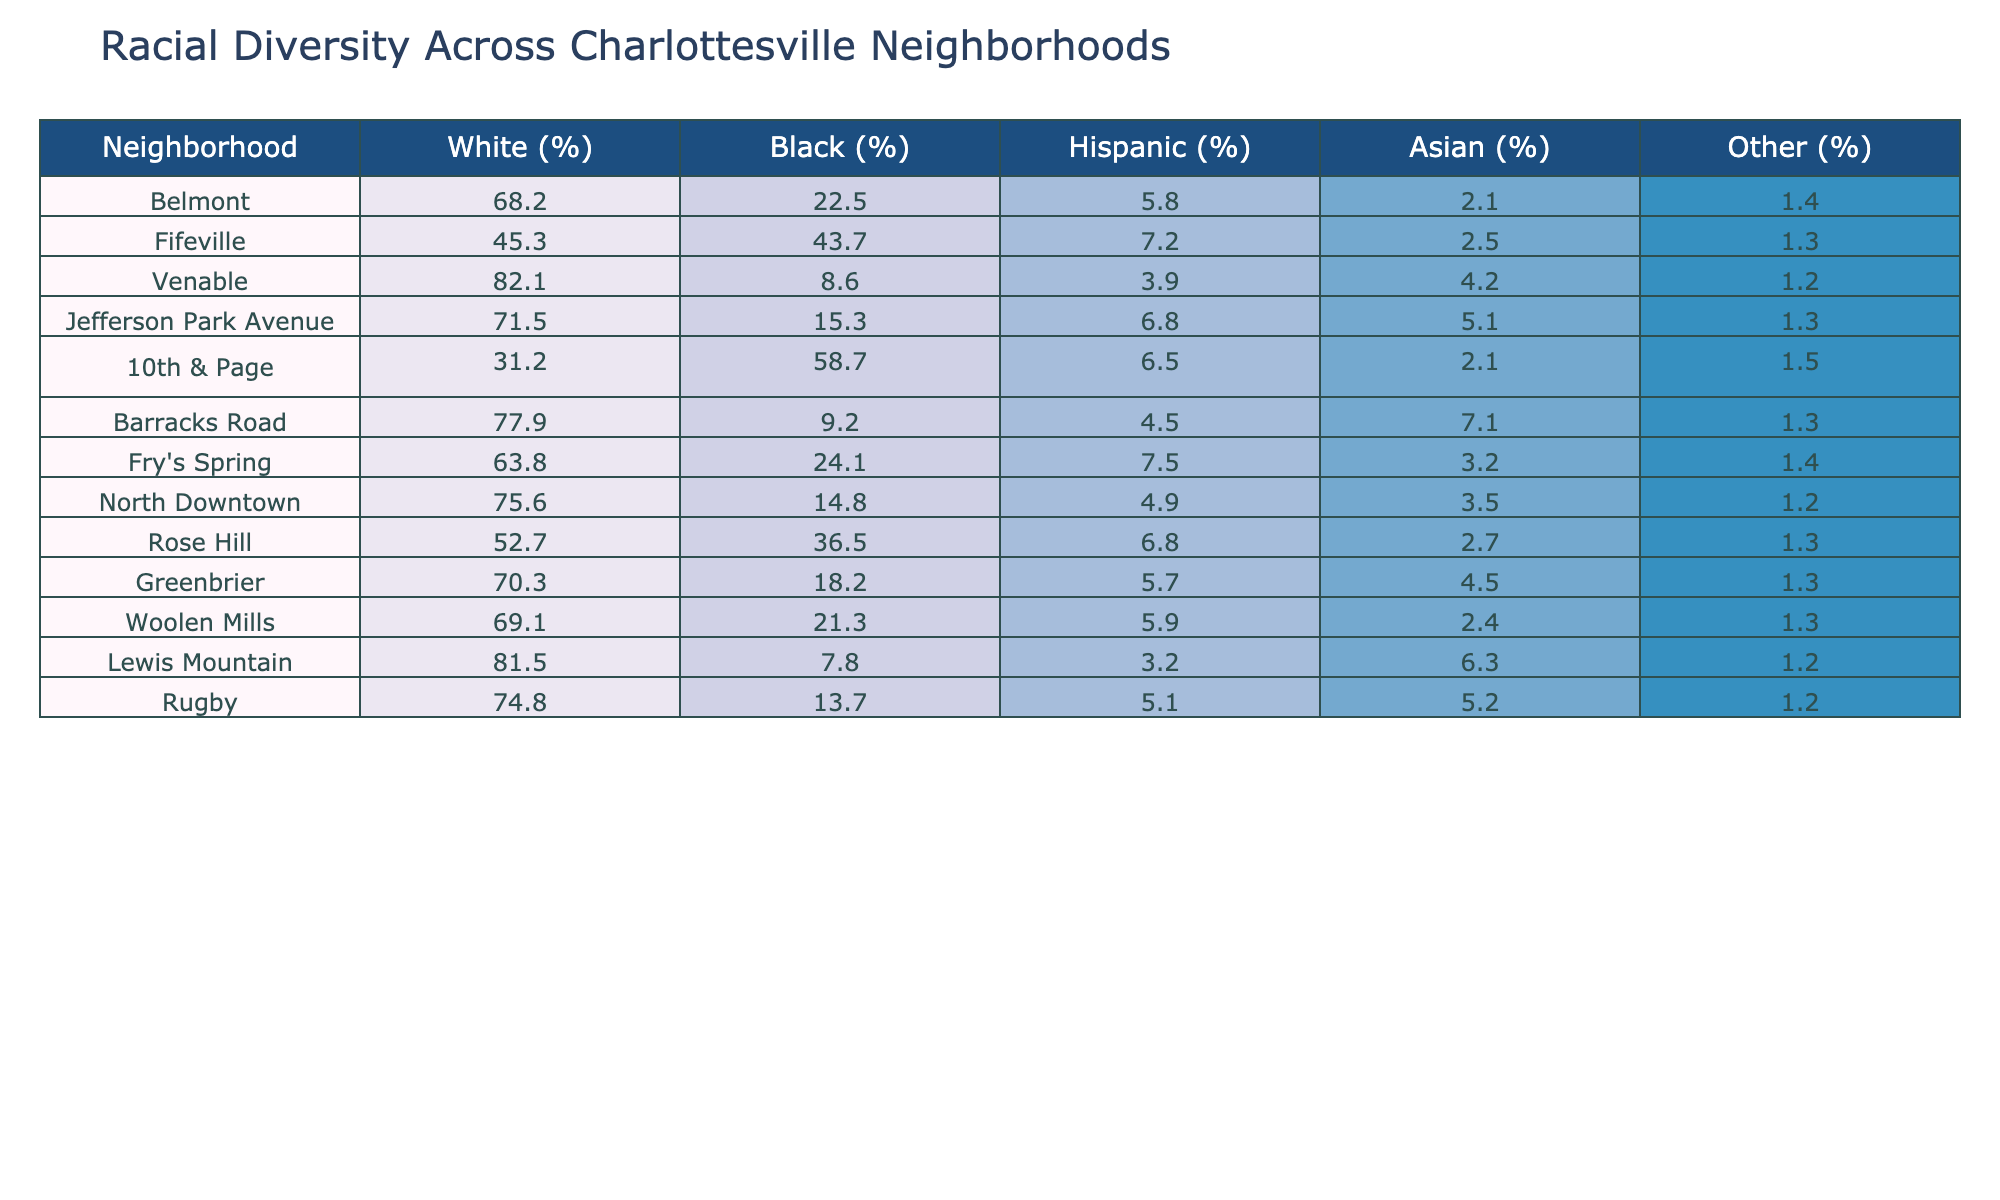What is the racial percentage of Black residents in the neighborhood of Fifeville? The table shows that Fifeville has 43.7% Black residents, which is directly listed under the Black (%) column for that neighborhood.
Answer: 43.7% Which neighborhood has the highest percentage of White residents? Looking through the table, Venable has the highest percentage of White residents at 82.1%, as seen in the White (%) column.
Answer: 82.1% What is the combined percentage of Hispanic and Asian residents in the neighborhood of 10th & Page? To find the combined percentage, you add the Hispanic percentage (6.5%) and the Asian percentage (2.1%) for 10th & Page. So, 6.5 + 2.1 = 8.6%.
Answer: 8.6% Which neighborhood has a higher percentage of Black residents: Woolen Mills or Fry's Spring? Woolen Mills has 21.3% Black residents, while Fry's Spring has 24.1%. Since 24.1% is greater than 21.3%, Fry's Spring has a higher percentage of Black residents.
Answer: Fry's Spring Is the percentage of White residents in Rose Hill above or below the overall average percentage across all neighborhoods? First, you need to calculate the average percentage of White residents by summing up all the White percentages (68.2 + 45.3 + 82.1 + 71.5 + 31.2 + 77.9 + 63.8 + 75.6 + 70.3 + 69.1 + 81.5 + 74.8 =  728.6) and then dividing by the number of neighborhoods (12). This gives about 60.7% (728.6 / 12). Rose Hill has 52.7%, which is below the average.
Answer: Below What are the two neighborhoods with the lowest percentage of Hispanic residents? From the table, we see that both Venable and Lewis Mountain have the lowest percentage of Hispanic residents at 3.9% and 3.2%, respectively. Therefore, they are the two neighborhoods with the lowest percentages.
Answer: Venable and Lewis Mountain Which neighborhood has the largest percentage difference between White and Black residents? To find the largest difference, we calculate the difference for each neighborhood: Belmont (68.2 - 22.5 = 45.7), Fifeville (45.3 - 43.7 = 1.6), Venable (82.1 - 8.6 = 73.5), Jefferson Park Avenue (71.5 - 15.3 = 56.2), 10th & Page (31.2 - 58.7 = -27.5), Barracks Road (77.9 - 9.2 = 68.7), Fry's Spring (63.8 - 24.1 = 39.7), North Downtown (75.6 - 14.8 = 60.8), Rose Hill (52.7 - 36.5 = 16.2), Greenbrier (70.3 - 18.2 = 52.1), Woolen Mills (69.1 - 21.3 = 47.8), and Lewis Mountain (81.5 - 7.8 = 73.7), and Rugby (74.8 - 13.7 = 61.1). The maximum calculated difference is therefore from Venable with 73.5%.
Answer: Venable 